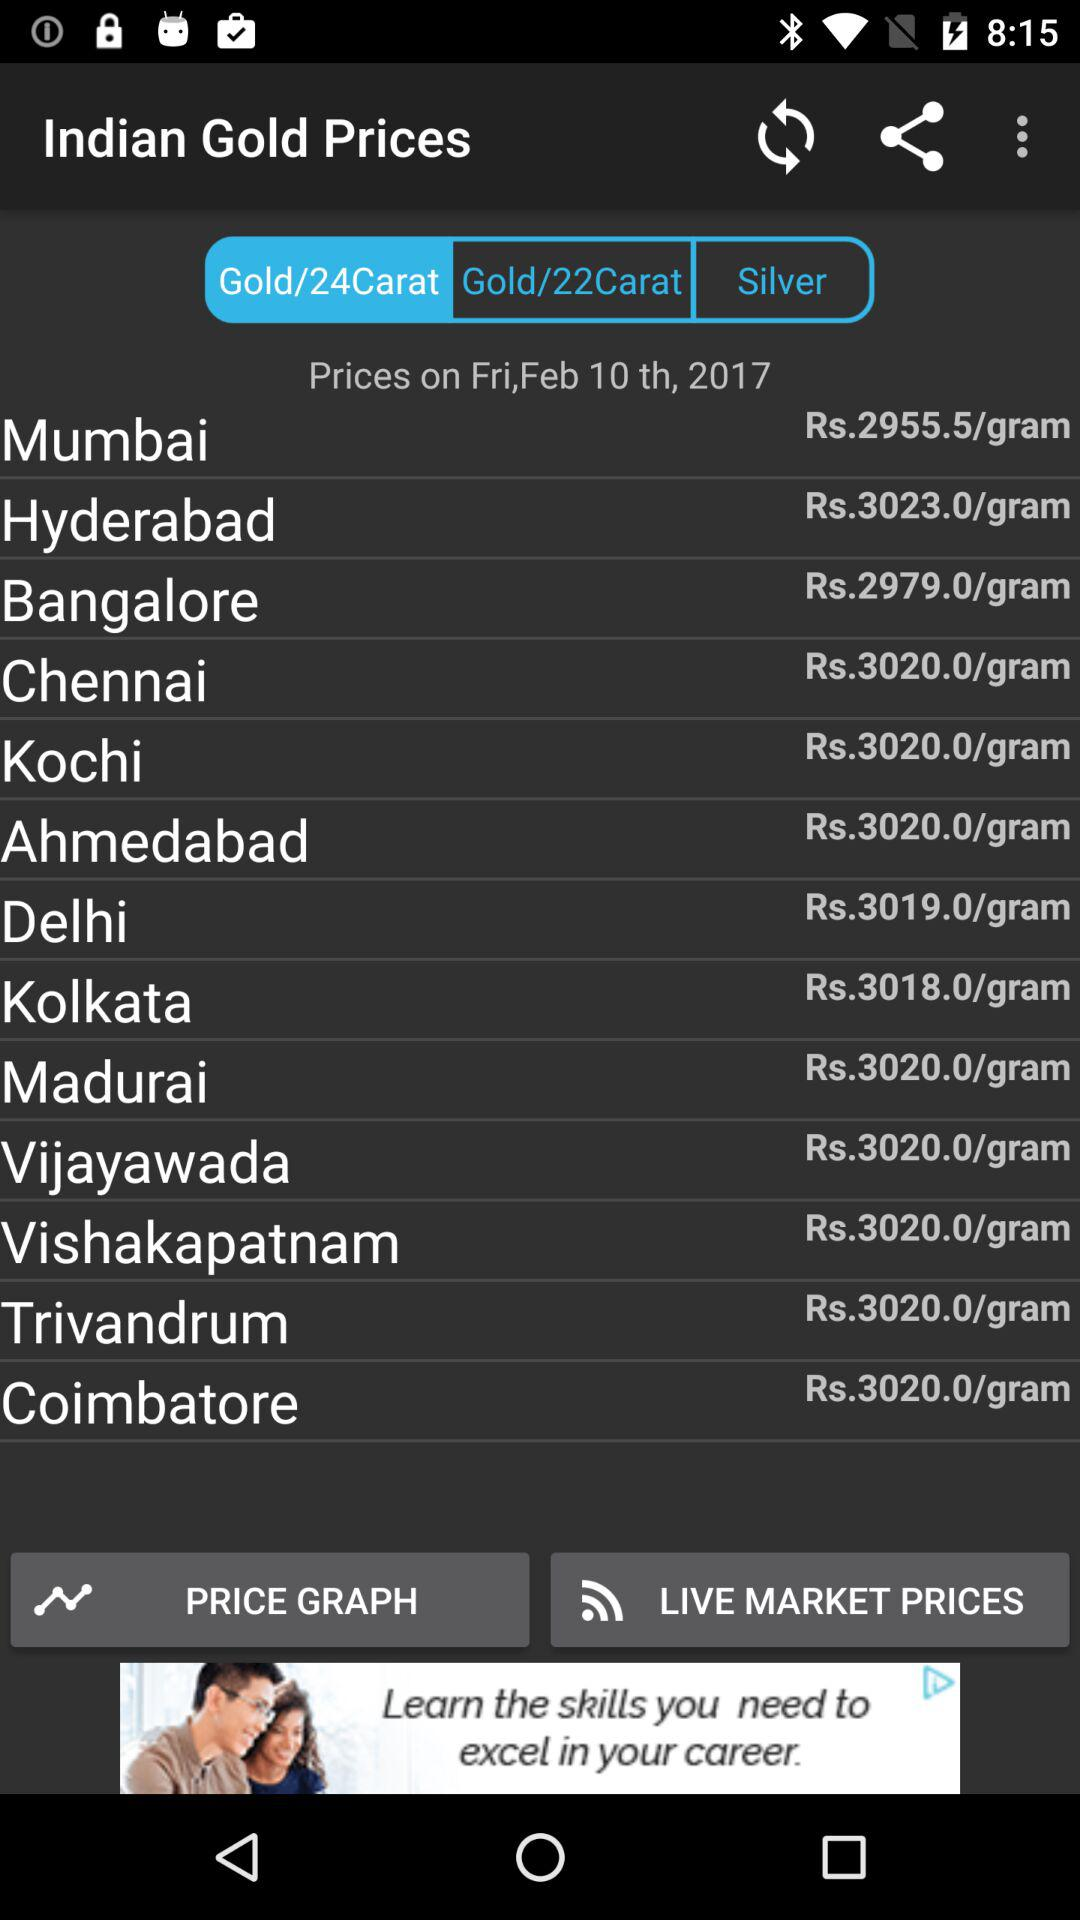What is the price of gold in Mumbai? The price is Rs. 2955.5/gram. 